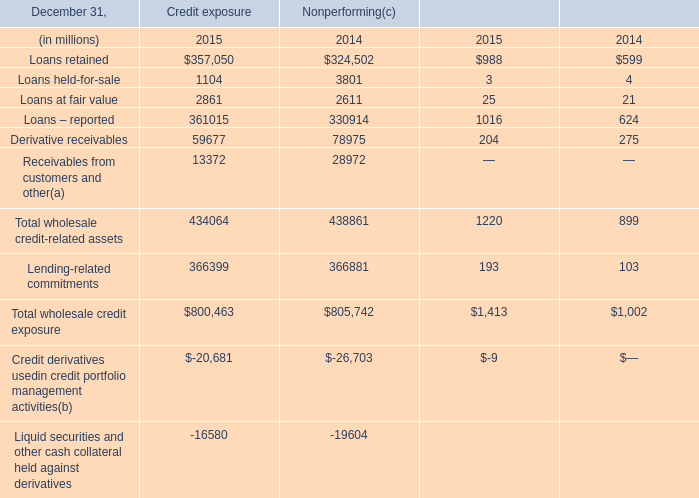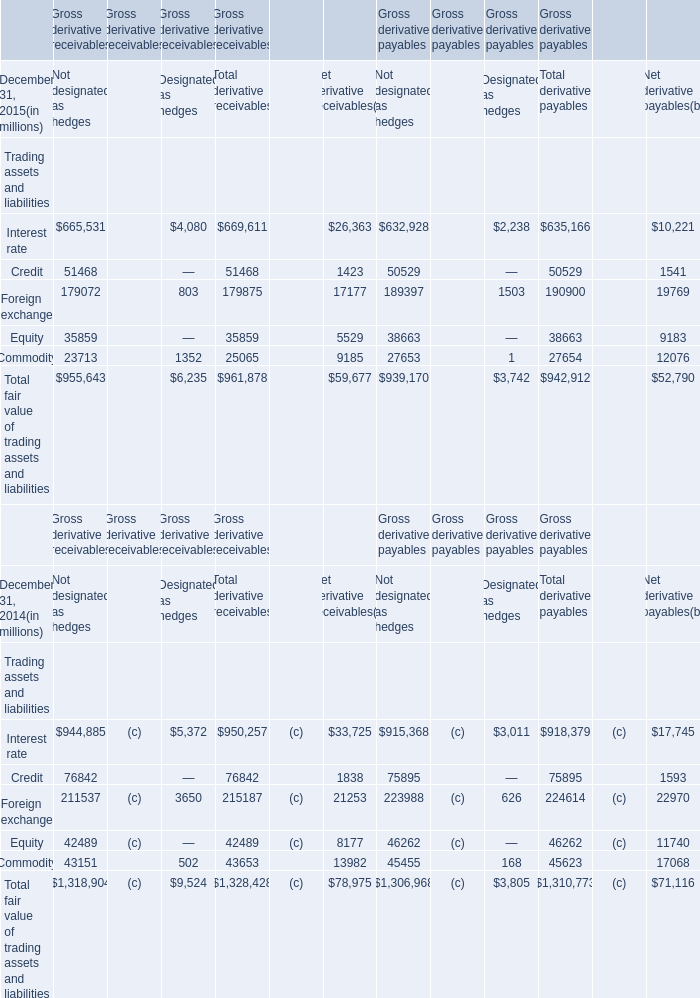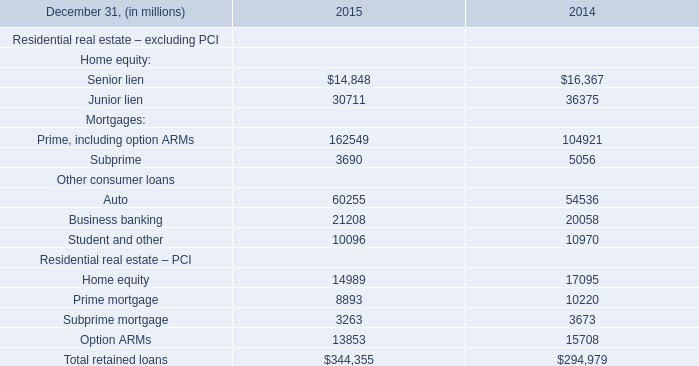What is the total amount of Loans – reported of Credit exposure 2015, and Auto Other consumer loans of 2014 ? 
Computations: (361015.0 + 54536.0)
Answer: 415551.0. 